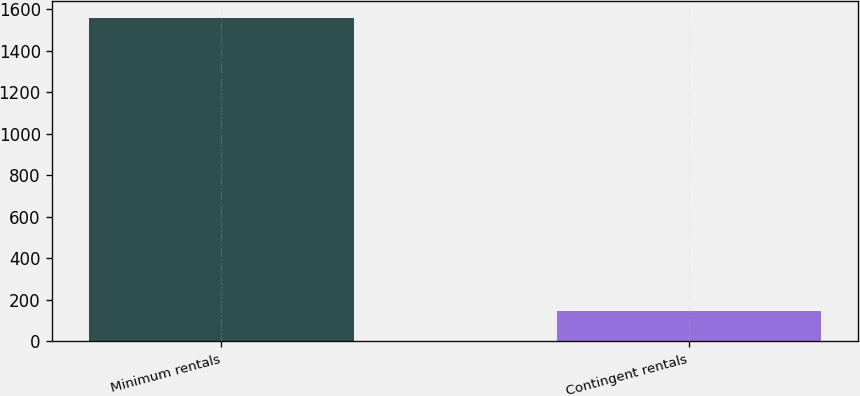Convert chart. <chart><loc_0><loc_0><loc_500><loc_500><bar_chart><fcel>Minimum rentals<fcel>Contingent rentals<nl><fcel>1560<fcel>143<nl></chart> 